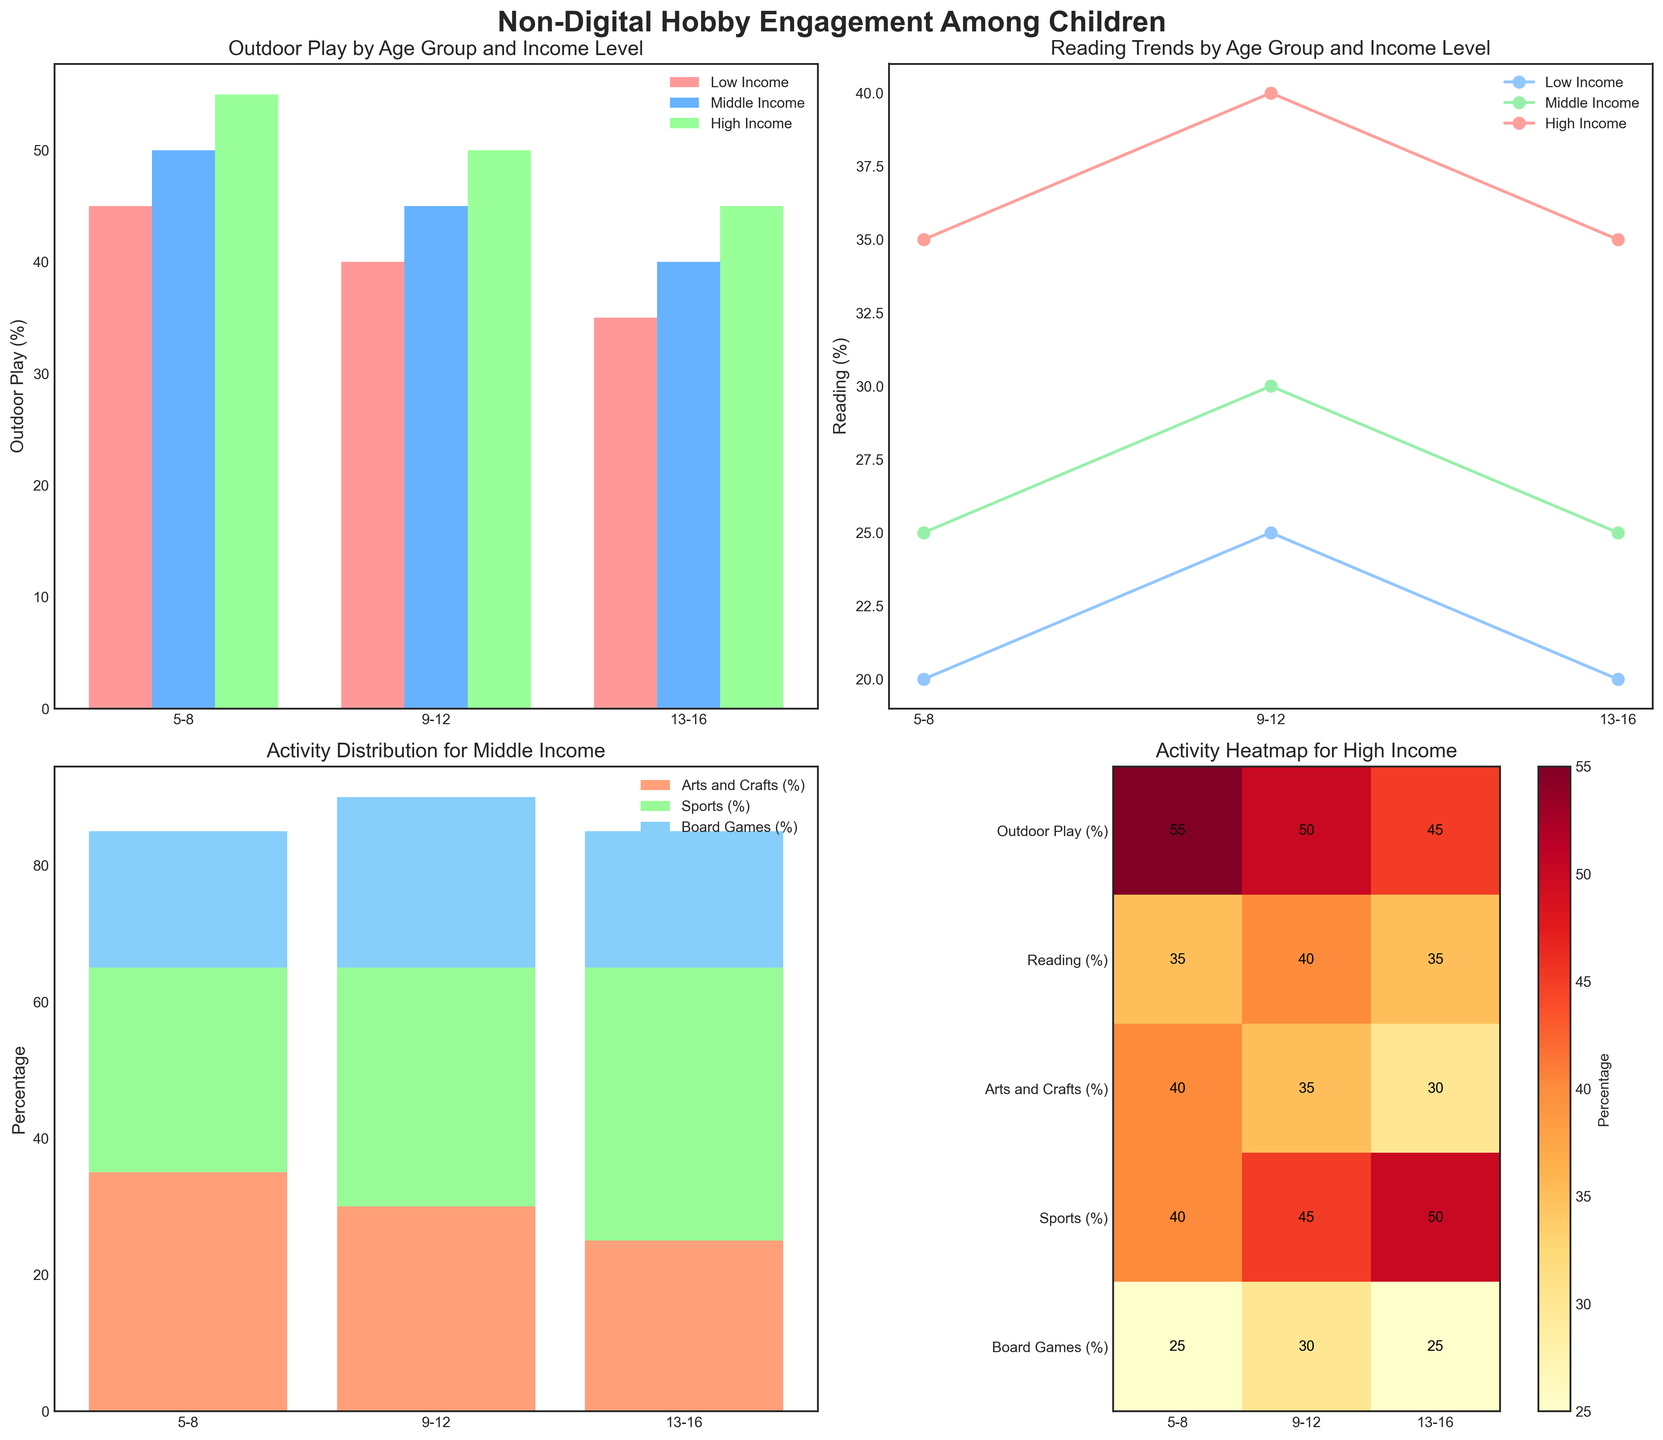What's the title of the figure? The title is typically displayed at the top of a figure. In this figure, it is "Non-Digital Hobby Engagement Among Children".
Answer: "Non-Digital Hobby Engagement Among Children" What percentage of high-income children aged 5-8 engage in outdoor play? Looking at the bar chart on the top left, for high-income levels, the bar is at 55%.
Answer: 55% Which age group has the highest engagement in reading among high-income children? In the line chart on the top right, the highest point for the high-income line (green) is at the age group 9-12.
Answer: 9-12 What's the trend in reading engagement from ages 5-16 for middle-income children? The line chart on the top right shows an increasing trend for the middle-income group from 25% to 35%.
Answer: Increasing What's the combined percentage for 'Arts and Crafts', 'Sports', and 'Board Games' among middle-income children aged 9-12? In the stacked bar chart at the bottom left, add the percentages of 'Arts and Crafts' (30%), 'Sports' (35%), and 'Board Games' (25%).
Answer: 90% How does 'Sports' engagement change across age groups for low-income children? In the stacked bar chart, we see Low Income children start at 25% in the 5-8 age group, increase to 30% in 9-12, and 35% in 13-16.
Answer: Increasing Which income group has the lowest 'Outdoor Play' engagement for the 9-12 age group? The bar chart on the top left shows that the low-income group (light red) has the lowest bar at 40%.
Answer: Low Income In the heatmap, which age group has the highest 'Board Games' engagement for high-income children? The heatmap at the bottom right shows that the 9-12 age group has the highest value at 30% for high-income.
Answer: 9-12 What activity is least engaged in by high-income children aged 13-16 according to the heatmap? The color of squares indicates engagement percentage. For high-income 13-16, the least engaged activity is 'Arts and Crafts' at 30%.
Answer: Arts and Crafts 